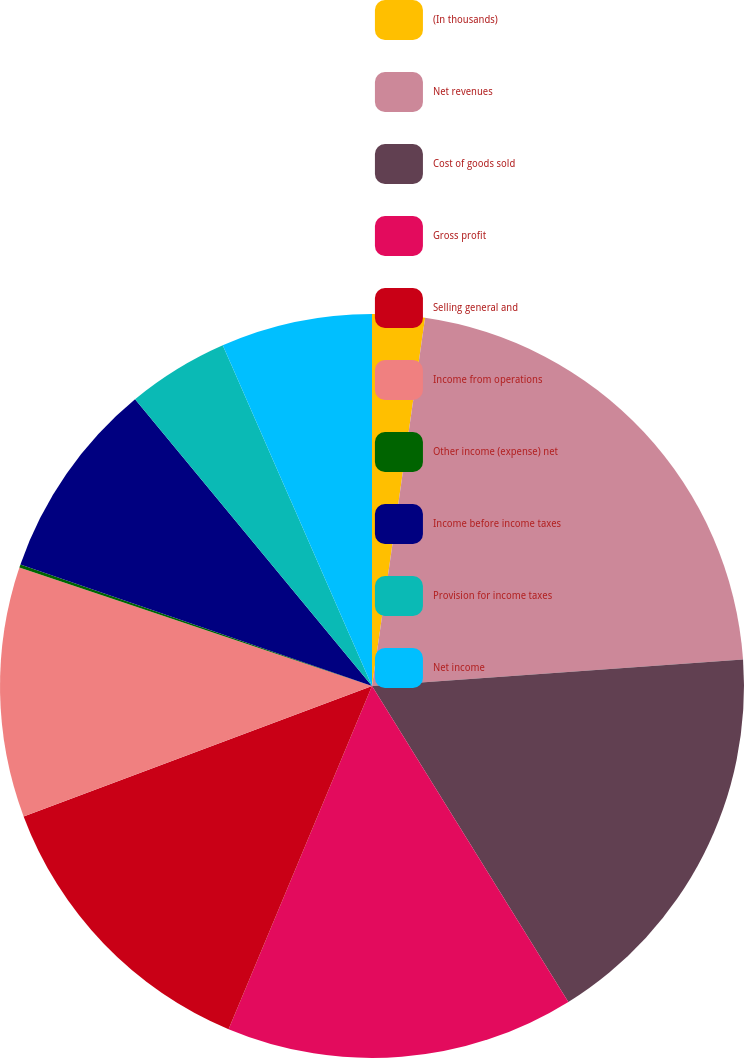<chart> <loc_0><loc_0><loc_500><loc_500><pie_chart><fcel>(In thousands)<fcel>Net revenues<fcel>Cost of goods sold<fcel>Gross profit<fcel>Selling general and<fcel>Income from operations<fcel>Other income (expense) net<fcel>Income before income taxes<fcel>Provision for income taxes<fcel>Net income<nl><fcel>2.28%<fcel>21.58%<fcel>17.29%<fcel>15.15%<fcel>13.0%<fcel>10.86%<fcel>0.14%<fcel>8.71%<fcel>4.42%<fcel>6.57%<nl></chart> 